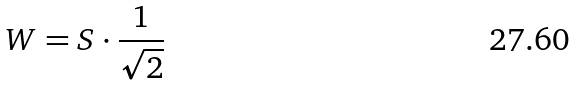Convert formula to latex. <formula><loc_0><loc_0><loc_500><loc_500>W = S \cdot \frac { 1 } { \sqrt { 2 } }</formula> 